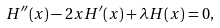<formula> <loc_0><loc_0><loc_500><loc_500>H ^ { \prime \prime } ( x ) - 2 x H ^ { \prime } ( x ) + \lambda H ( x ) = 0 ,</formula> 